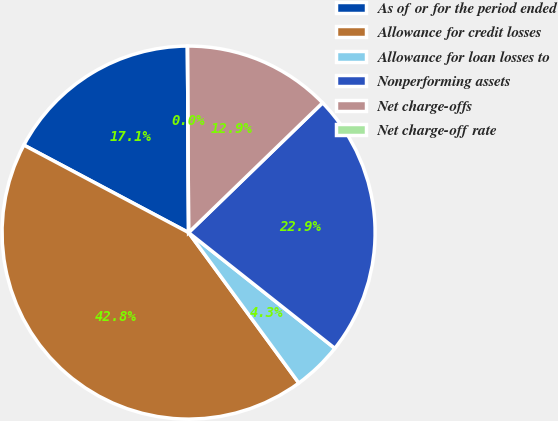Convert chart to OTSL. <chart><loc_0><loc_0><loc_500><loc_500><pie_chart><fcel>As of or for the period ended<fcel>Allowance for credit losses<fcel>Allowance for loan losses to<fcel>Nonperforming assets<fcel>Net charge-offs<fcel>Net charge-off rate<nl><fcel>17.13%<fcel>42.83%<fcel>4.28%<fcel>22.9%<fcel>12.85%<fcel>0.0%<nl></chart> 